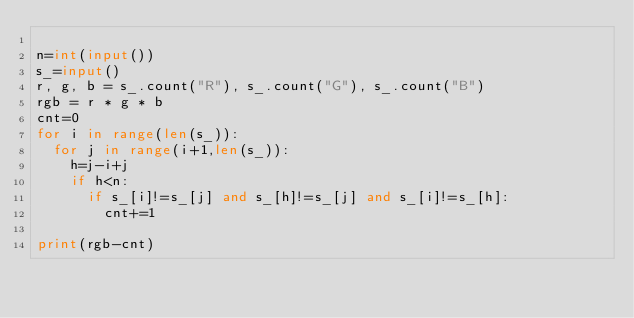Convert code to text. <code><loc_0><loc_0><loc_500><loc_500><_Python_>
n=int(input())
s_=input()
r, g, b = s_.count("R"), s_.count("G"), s_.count("B")
rgb = r * g * b
cnt=0
for i in range(len(s_)):
  for j in range(i+1,len(s_)):
    h=j-i+j
    if h<n:
      if s_[i]!=s_[j] and s_[h]!=s_[j] and s_[i]!=s_[h]:
        cnt+=1

print(rgb-cnt)
    </code> 